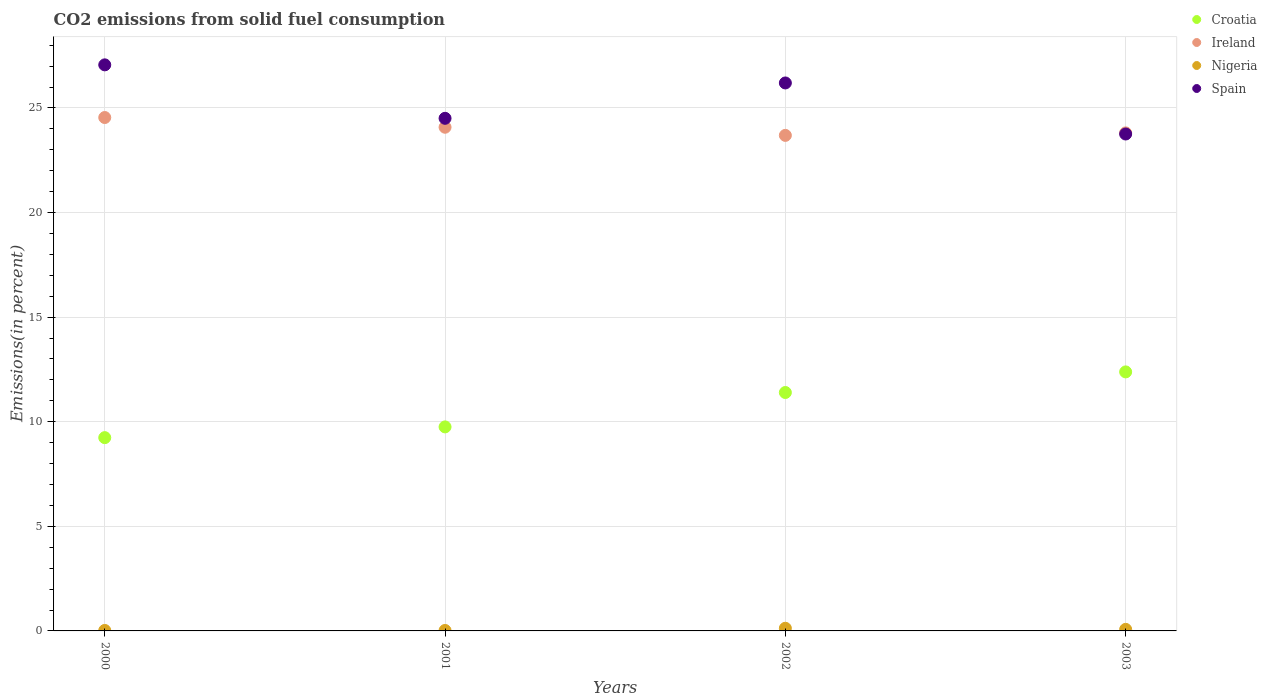How many different coloured dotlines are there?
Give a very brief answer. 4. What is the total CO2 emitted in Croatia in 2001?
Your answer should be compact. 9.75. Across all years, what is the maximum total CO2 emitted in Nigeria?
Make the answer very short. 0.13. Across all years, what is the minimum total CO2 emitted in Croatia?
Provide a succinct answer. 9.24. What is the total total CO2 emitted in Ireland in the graph?
Your response must be concise. 96.12. What is the difference between the total CO2 emitted in Spain in 2000 and that in 2003?
Offer a terse response. 3.31. What is the difference between the total CO2 emitted in Croatia in 2002 and the total CO2 emitted in Nigeria in 2000?
Provide a succinct answer. 11.37. What is the average total CO2 emitted in Ireland per year?
Your answer should be very brief. 24.03. In the year 2003, what is the difference between the total CO2 emitted in Ireland and total CO2 emitted in Nigeria?
Offer a very short reply. 23.73. What is the ratio of the total CO2 emitted in Croatia in 2002 to that in 2003?
Provide a short and direct response. 0.92. What is the difference between the highest and the second highest total CO2 emitted in Nigeria?
Provide a short and direct response. 0.05. What is the difference between the highest and the lowest total CO2 emitted in Ireland?
Ensure brevity in your answer.  0.85. In how many years, is the total CO2 emitted in Spain greater than the average total CO2 emitted in Spain taken over all years?
Offer a terse response. 2. Is the sum of the total CO2 emitted in Spain in 2001 and 2003 greater than the maximum total CO2 emitted in Croatia across all years?
Keep it short and to the point. Yes. Does the total CO2 emitted in Nigeria monotonically increase over the years?
Provide a succinct answer. No. Is the total CO2 emitted in Nigeria strictly greater than the total CO2 emitted in Ireland over the years?
Provide a short and direct response. No. Is the total CO2 emitted in Nigeria strictly less than the total CO2 emitted in Spain over the years?
Offer a terse response. Yes. How many dotlines are there?
Your response must be concise. 4. How many years are there in the graph?
Keep it short and to the point. 4. Are the values on the major ticks of Y-axis written in scientific E-notation?
Give a very brief answer. No. Does the graph contain any zero values?
Make the answer very short. No. How many legend labels are there?
Offer a terse response. 4. How are the legend labels stacked?
Keep it short and to the point. Vertical. What is the title of the graph?
Your answer should be compact. CO2 emissions from solid fuel consumption. Does "Fragile and conflict affected situations" appear as one of the legend labels in the graph?
Your response must be concise. No. What is the label or title of the X-axis?
Your response must be concise. Years. What is the label or title of the Y-axis?
Your response must be concise. Emissions(in percent). What is the Emissions(in percent) of Croatia in 2000?
Your answer should be very brief. 9.24. What is the Emissions(in percent) in Ireland in 2000?
Keep it short and to the point. 24.54. What is the Emissions(in percent) of Nigeria in 2000?
Give a very brief answer. 0.02. What is the Emissions(in percent) of Spain in 2000?
Provide a short and direct response. 27.06. What is the Emissions(in percent) in Croatia in 2001?
Your answer should be very brief. 9.75. What is the Emissions(in percent) of Ireland in 2001?
Offer a very short reply. 24.08. What is the Emissions(in percent) in Nigeria in 2001?
Keep it short and to the point. 0.02. What is the Emissions(in percent) in Spain in 2001?
Provide a succinct answer. 24.51. What is the Emissions(in percent) in Croatia in 2002?
Ensure brevity in your answer.  11.4. What is the Emissions(in percent) of Ireland in 2002?
Your answer should be compact. 23.69. What is the Emissions(in percent) in Nigeria in 2002?
Ensure brevity in your answer.  0.13. What is the Emissions(in percent) of Spain in 2002?
Keep it short and to the point. 26.2. What is the Emissions(in percent) in Croatia in 2003?
Your response must be concise. 12.38. What is the Emissions(in percent) of Ireland in 2003?
Your answer should be very brief. 23.81. What is the Emissions(in percent) of Nigeria in 2003?
Provide a succinct answer. 0.07. What is the Emissions(in percent) in Spain in 2003?
Your answer should be very brief. 23.76. Across all years, what is the maximum Emissions(in percent) in Croatia?
Offer a terse response. 12.38. Across all years, what is the maximum Emissions(in percent) in Ireland?
Ensure brevity in your answer.  24.54. Across all years, what is the maximum Emissions(in percent) of Nigeria?
Your answer should be compact. 0.13. Across all years, what is the maximum Emissions(in percent) of Spain?
Your answer should be very brief. 27.06. Across all years, what is the minimum Emissions(in percent) of Croatia?
Provide a short and direct response. 9.24. Across all years, what is the minimum Emissions(in percent) of Ireland?
Keep it short and to the point. 23.69. Across all years, what is the minimum Emissions(in percent) of Nigeria?
Provide a short and direct response. 0.02. Across all years, what is the minimum Emissions(in percent) of Spain?
Provide a short and direct response. 23.76. What is the total Emissions(in percent) of Croatia in the graph?
Make the answer very short. 42.78. What is the total Emissions(in percent) of Ireland in the graph?
Give a very brief answer. 96.12. What is the total Emissions(in percent) of Nigeria in the graph?
Ensure brevity in your answer.  0.25. What is the total Emissions(in percent) of Spain in the graph?
Your answer should be very brief. 101.52. What is the difference between the Emissions(in percent) of Croatia in 2000 and that in 2001?
Your response must be concise. -0.51. What is the difference between the Emissions(in percent) of Ireland in 2000 and that in 2001?
Keep it short and to the point. 0.46. What is the difference between the Emissions(in percent) of Nigeria in 2000 and that in 2001?
Your answer should be very brief. 0. What is the difference between the Emissions(in percent) of Spain in 2000 and that in 2001?
Offer a very short reply. 2.56. What is the difference between the Emissions(in percent) in Croatia in 2000 and that in 2002?
Offer a terse response. -2.16. What is the difference between the Emissions(in percent) of Ireland in 2000 and that in 2002?
Ensure brevity in your answer.  0.85. What is the difference between the Emissions(in percent) in Nigeria in 2000 and that in 2002?
Keep it short and to the point. -0.1. What is the difference between the Emissions(in percent) in Spain in 2000 and that in 2002?
Your response must be concise. 0.87. What is the difference between the Emissions(in percent) in Croatia in 2000 and that in 2003?
Make the answer very short. -3.14. What is the difference between the Emissions(in percent) in Ireland in 2000 and that in 2003?
Make the answer very short. 0.73. What is the difference between the Emissions(in percent) in Nigeria in 2000 and that in 2003?
Offer a terse response. -0.05. What is the difference between the Emissions(in percent) in Spain in 2000 and that in 2003?
Keep it short and to the point. 3.31. What is the difference between the Emissions(in percent) in Croatia in 2001 and that in 2002?
Your response must be concise. -1.64. What is the difference between the Emissions(in percent) in Ireland in 2001 and that in 2002?
Your answer should be very brief. 0.39. What is the difference between the Emissions(in percent) of Nigeria in 2001 and that in 2002?
Your answer should be very brief. -0.11. What is the difference between the Emissions(in percent) of Spain in 2001 and that in 2002?
Your answer should be very brief. -1.69. What is the difference between the Emissions(in percent) in Croatia in 2001 and that in 2003?
Keep it short and to the point. -2.63. What is the difference between the Emissions(in percent) of Ireland in 2001 and that in 2003?
Give a very brief answer. 0.27. What is the difference between the Emissions(in percent) of Nigeria in 2001 and that in 2003?
Your answer should be very brief. -0.05. What is the difference between the Emissions(in percent) of Spain in 2001 and that in 2003?
Offer a very short reply. 0.75. What is the difference between the Emissions(in percent) in Croatia in 2002 and that in 2003?
Offer a very short reply. -0.99. What is the difference between the Emissions(in percent) in Ireland in 2002 and that in 2003?
Your answer should be very brief. -0.12. What is the difference between the Emissions(in percent) of Nigeria in 2002 and that in 2003?
Provide a succinct answer. 0.05. What is the difference between the Emissions(in percent) in Spain in 2002 and that in 2003?
Give a very brief answer. 2.44. What is the difference between the Emissions(in percent) of Croatia in 2000 and the Emissions(in percent) of Ireland in 2001?
Your response must be concise. -14.84. What is the difference between the Emissions(in percent) of Croatia in 2000 and the Emissions(in percent) of Nigeria in 2001?
Give a very brief answer. 9.22. What is the difference between the Emissions(in percent) of Croatia in 2000 and the Emissions(in percent) of Spain in 2001?
Provide a succinct answer. -15.27. What is the difference between the Emissions(in percent) in Ireland in 2000 and the Emissions(in percent) in Nigeria in 2001?
Offer a terse response. 24.52. What is the difference between the Emissions(in percent) in Ireland in 2000 and the Emissions(in percent) in Spain in 2001?
Provide a short and direct response. 0.04. What is the difference between the Emissions(in percent) in Nigeria in 2000 and the Emissions(in percent) in Spain in 2001?
Your answer should be compact. -24.48. What is the difference between the Emissions(in percent) of Croatia in 2000 and the Emissions(in percent) of Ireland in 2002?
Offer a very short reply. -14.45. What is the difference between the Emissions(in percent) in Croatia in 2000 and the Emissions(in percent) in Nigeria in 2002?
Offer a very short reply. 9.11. What is the difference between the Emissions(in percent) in Croatia in 2000 and the Emissions(in percent) in Spain in 2002?
Offer a terse response. -16.96. What is the difference between the Emissions(in percent) in Ireland in 2000 and the Emissions(in percent) in Nigeria in 2002?
Your answer should be very brief. 24.42. What is the difference between the Emissions(in percent) of Ireland in 2000 and the Emissions(in percent) of Spain in 2002?
Offer a very short reply. -1.65. What is the difference between the Emissions(in percent) in Nigeria in 2000 and the Emissions(in percent) in Spain in 2002?
Make the answer very short. -26.17. What is the difference between the Emissions(in percent) of Croatia in 2000 and the Emissions(in percent) of Ireland in 2003?
Make the answer very short. -14.57. What is the difference between the Emissions(in percent) in Croatia in 2000 and the Emissions(in percent) in Nigeria in 2003?
Give a very brief answer. 9.17. What is the difference between the Emissions(in percent) in Croatia in 2000 and the Emissions(in percent) in Spain in 2003?
Your answer should be compact. -14.52. What is the difference between the Emissions(in percent) in Ireland in 2000 and the Emissions(in percent) in Nigeria in 2003?
Keep it short and to the point. 24.47. What is the difference between the Emissions(in percent) in Ireland in 2000 and the Emissions(in percent) in Spain in 2003?
Your answer should be very brief. 0.79. What is the difference between the Emissions(in percent) of Nigeria in 2000 and the Emissions(in percent) of Spain in 2003?
Your answer should be compact. -23.73. What is the difference between the Emissions(in percent) of Croatia in 2001 and the Emissions(in percent) of Ireland in 2002?
Keep it short and to the point. -13.94. What is the difference between the Emissions(in percent) of Croatia in 2001 and the Emissions(in percent) of Nigeria in 2002?
Make the answer very short. 9.63. What is the difference between the Emissions(in percent) of Croatia in 2001 and the Emissions(in percent) of Spain in 2002?
Your response must be concise. -16.44. What is the difference between the Emissions(in percent) in Ireland in 2001 and the Emissions(in percent) in Nigeria in 2002?
Offer a very short reply. 23.95. What is the difference between the Emissions(in percent) of Ireland in 2001 and the Emissions(in percent) of Spain in 2002?
Ensure brevity in your answer.  -2.12. What is the difference between the Emissions(in percent) in Nigeria in 2001 and the Emissions(in percent) in Spain in 2002?
Your response must be concise. -26.17. What is the difference between the Emissions(in percent) in Croatia in 2001 and the Emissions(in percent) in Ireland in 2003?
Your answer should be very brief. -14.06. What is the difference between the Emissions(in percent) of Croatia in 2001 and the Emissions(in percent) of Nigeria in 2003?
Your response must be concise. 9.68. What is the difference between the Emissions(in percent) of Croatia in 2001 and the Emissions(in percent) of Spain in 2003?
Your answer should be compact. -14. What is the difference between the Emissions(in percent) in Ireland in 2001 and the Emissions(in percent) in Nigeria in 2003?
Your answer should be compact. 24. What is the difference between the Emissions(in percent) of Ireland in 2001 and the Emissions(in percent) of Spain in 2003?
Provide a short and direct response. 0.32. What is the difference between the Emissions(in percent) of Nigeria in 2001 and the Emissions(in percent) of Spain in 2003?
Give a very brief answer. -23.73. What is the difference between the Emissions(in percent) of Croatia in 2002 and the Emissions(in percent) of Ireland in 2003?
Keep it short and to the point. -12.41. What is the difference between the Emissions(in percent) of Croatia in 2002 and the Emissions(in percent) of Nigeria in 2003?
Your answer should be compact. 11.32. What is the difference between the Emissions(in percent) of Croatia in 2002 and the Emissions(in percent) of Spain in 2003?
Your answer should be very brief. -12.36. What is the difference between the Emissions(in percent) of Ireland in 2002 and the Emissions(in percent) of Nigeria in 2003?
Give a very brief answer. 23.62. What is the difference between the Emissions(in percent) of Ireland in 2002 and the Emissions(in percent) of Spain in 2003?
Offer a very short reply. -0.07. What is the difference between the Emissions(in percent) in Nigeria in 2002 and the Emissions(in percent) in Spain in 2003?
Your answer should be compact. -23.63. What is the average Emissions(in percent) of Croatia per year?
Offer a terse response. 10.69. What is the average Emissions(in percent) of Ireland per year?
Give a very brief answer. 24.03. What is the average Emissions(in percent) in Nigeria per year?
Ensure brevity in your answer.  0.06. What is the average Emissions(in percent) in Spain per year?
Your answer should be compact. 25.38. In the year 2000, what is the difference between the Emissions(in percent) in Croatia and Emissions(in percent) in Ireland?
Your answer should be very brief. -15.3. In the year 2000, what is the difference between the Emissions(in percent) of Croatia and Emissions(in percent) of Nigeria?
Your answer should be very brief. 9.22. In the year 2000, what is the difference between the Emissions(in percent) in Croatia and Emissions(in percent) in Spain?
Your answer should be very brief. -17.82. In the year 2000, what is the difference between the Emissions(in percent) of Ireland and Emissions(in percent) of Nigeria?
Ensure brevity in your answer.  24.52. In the year 2000, what is the difference between the Emissions(in percent) of Ireland and Emissions(in percent) of Spain?
Ensure brevity in your answer.  -2.52. In the year 2000, what is the difference between the Emissions(in percent) in Nigeria and Emissions(in percent) in Spain?
Your answer should be compact. -27.04. In the year 2001, what is the difference between the Emissions(in percent) in Croatia and Emissions(in percent) in Ireland?
Ensure brevity in your answer.  -14.33. In the year 2001, what is the difference between the Emissions(in percent) in Croatia and Emissions(in percent) in Nigeria?
Your answer should be compact. 9.73. In the year 2001, what is the difference between the Emissions(in percent) of Croatia and Emissions(in percent) of Spain?
Make the answer very short. -14.75. In the year 2001, what is the difference between the Emissions(in percent) of Ireland and Emissions(in percent) of Nigeria?
Provide a short and direct response. 24.06. In the year 2001, what is the difference between the Emissions(in percent) of Ireland and Emissions(in percent) of Spain?
Your answer should be compact. -0.43. In the year 2001, what is the difference between the Emissions(in percent) of Nigeria and Emissions(in percent) of Spain?
Your answer should be compact. -24.48. In the year 2002, what is the difference between the Emissions(in percent) in Croatia and Emissions(in percent) in Ireland?
Offer a very short reply. -12.29. In the year 2002, what is the difference between the Emissions(in percent) in Croatia and Emissions(in percent) in Nigeria?
Make the answer very short. 11.27. In the year 2002, what is the difference between the Emissions(in percent) in Croatia and Emissions(in percent) in Spain?
Your answer should be compact. -14.8. In the year 2002, what is the difference between the Emissions(in percent) of Ireland and Emissions(in percent) of Nigeria?
Provide a succinct answer. 23.56. In the year 2002, what is the difference between the Emissions(in percent) of Ireland and Emissions(in percent) of Spain?
Give a very brief answer. -2.51. In the year 2002, what is the difference between the Emissions(in percent) in Nigeria and Emissions(in percent) in Spain?
Give a very brief answer. -26.07. In the year 2003, what is the difference between the Emissions(in percent) in Croatia and Emissions(in percent) in Ireland?
Your response must be concise. -11.43. In the year 2003, what is the difference between the Emissions(in percent) of Croatia and Emissions(in percent) of Nigeria?
Provide a succinct answer. 12.31. In the year 2003, what is the difference between the Emissions(in percent) in Croatia and Emissions(in percent) in Spain?
Make the answer very short. -11.37. In the year 2003, what is the difference between the Emissions(in percent) in Ireland and Emissions(in percent) in Nigeria?
Keep it short and to the point. 23.73. In the year 2003, what is the difference between the Emissions(in percent) of Ireland and Emissions(in percent) of Spain?
Ensure brevity in your answer.  0.05. In the year 2003, what is the difference between the Emissions(in percent) of Nigeria and Emissions(in percent) of Spain?
Your response must be concise. -23.68. What is the ratio of the Emissions(in percent) in Croatia in 2000 to that in 2001?
Give a very brief answer. 0.95. What is the ratio of the Emissions(in percent) in Ireland in 2000 to that in 2001?
Offer a terse response. 1.02. What is the ratio of the Emissions(in percent) in Nigeria in 2000 to that in 2001?
Your answer should be very brief. 1.05. What is the ratio of the Emissions(in percent) in Spain in 2000 to that in 2001?
Your response must be concise. 1.1. What is the ratio of the Emissions(in percent) of Croatia in 2000 to that in 2002?
Ensure brevity in your answer.  0.81. What is the ratio of the Emissions(in percent) in Ireland in 2000 to that in 2002?
Your answer should be compact. 1.04. What is the ratio of the Emissions(in percent) in Nigeria in 2000 to that in 2002?
Your answer should be compact. 0.18. What is the ratio of the Emissions(in percent) in Spain in 2000 to that in 2002?
Make the answer very short. 1.03. What is the ratio of the Emissions(in percent) of Croatia in 2000 to that in 2003?
Keep it short and to the point. 0.75. What is the ratio of the Emissions(in percent) of Ireland in 2000 to that in 2003?
Offer a very short reply. 1.03. What is the ratio of the Emissions(in percent) of Nigeria in 2000 to that in 2003?
Offer a terse response. 0.31. What is the ratio of the Emissions(in percent) of Spain in 2000 to that in 2003?
Provide a succinct answer. 1.14. What is the ratio of the Emissions(in percent) of Croatia in 2001 to that in 2002?
Your answer should be compact. 0.86. What is the ratio of the Emissions(in percent) in Ireland in 2001 to that in 2002?
Provide a short and direct response. 1.02. What is the ratio of the Emissions(in percent) of Nigeria in 2001 to that in 2002?
Give a very brief answer. 0.17. What is the ratio of the Emissions(in percent) of Spain in 2001 to that in 2002?
Ensure brevity in your answer.  0.94. What is the ratio of the Emissions(in percent) in Croatia in 2001 to that in 2003?
Give a very brief answer. 0.79. What is the ratio of the Emissions(in percent) in Ireland in 2001 to that in 2003?
Your answer should be very brief. 1.01. What is the ratio of the Emissions(in percent) of Nigeria in 2001 to that in 2003?
Provide a succinct answer. 0.29. What is the ratio of the Emissions(in percent) of Spain in 2001 to that in 2003?
Make the answer very short. 1.03. What is the ratio of the Emissions(in percent) in Croatia in 2002 to that in 2003?
Ensure brevity in your answer.  0.92. What is the ratio of the Emissions(in percent) in Ireland in 2002 to that in 2003?
Keep it short and to the point. 0.99. What is the ratio of the Emissions(in percent) in Nigeria in 2002 to that in 2003?
Offer a very short reply. 1.7. What is the ratio of the Emissions(in percent) in Spain in 2002 to that in 2003?
Keep it short and to the point. 1.1. What is the difference between the highest and the second highest Emissions(in percent) of Ireland?
Keep it short and to the point. 0.46. What is the difference between the highest and the second highest Emissions(in percent) of Nigeria?
Provide a short and direct response. 0.05. What is the difference between the highest and the second highest Emissions(in percent) of Spain?
Provide a succinct answer. 0.87. What is the difference between the highest and the lowest Emissions(in percent) in Croatia?
Provide a short and direct response. 3.14. What is the difference between the highest and the lowest Emissions(in percent) in Ireland?
Give a very brief answer. 0.85. What is the difference between the highest and the lowest Emissions(in percent) in Nigeria?
Offer a very short reply. 0.11. What is the difference between the highest and the lowest Emissions(in percent) in Spain?
Provide a short and direct response. 3.31. 